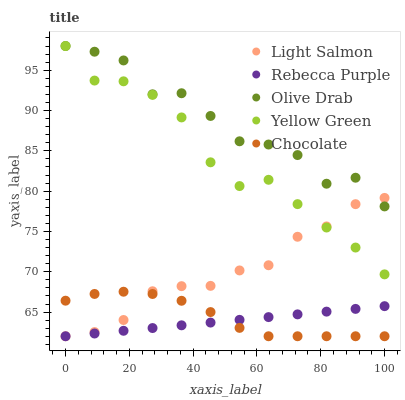Does Rebecca Purple have the minimum area under the curve?
Answer yes or no. Yes. Does Olive Drab have the maximum area under the curve?
Answer yes or no. Yes. Does Chocolate have the minimum area under the curve?
Answer yes or no. No. Does Chocolate have the maximum area under the curve?
Answer yes or no. No. Is Rebecca Purple the smoothest?
Answer yes or no. Yes. Is Olive Drab the roughest?
Answer yes or no. Yes. Is Chocolate the smoothest?
Answer yes or no. No. Is Chocolate the roughest?
Answer yes or no. No. Does Light Salmon have the lowest value?
Answer yes or no. Yes. Does Olive Drab have the lowest value?
Answer yes or no. No. Does Yellow Green have the highest value?
Answer yes or no. Yes. Does Chocolate have the highest value?
Answer yes or no. No. Is Chocolate less than Yellow Green?
Answer yes or no. Yes. Is Yellow Green greater than Rebecca Purple?
Answer yes or no. Yes. Does Light Salmon intersect Yellow Green?
Answer yes or no. Yes. Is Light Salmon less than Yellow Green?
Answer yes or no. No. Is Light Salmon greater than Yellow Green?
Answer yes or no. No. Does Chocolate intersect Yellow Green?
Answer yes or no. No. 